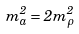<formula> <loc_0><loc_0><loc_500><loc_500>m ^ { 2 } _ { a } = 2 m ^ { 2 } _ { \rho }</formula> 